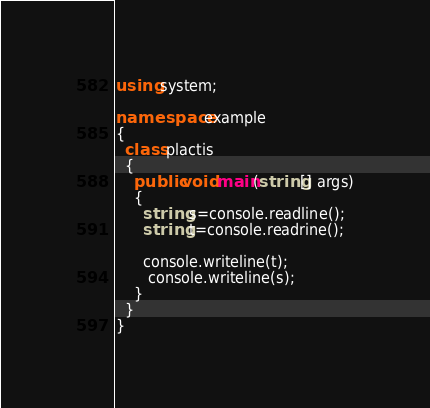Convert code to text. <code><loc_0><loc_0><loc_500><loc_500><_C#_>using system;
 
namespace example
{
  class plactis
  {
    public void main(string[] args)
    {
      string s=console.readline();
      string t=console.readrine();
      
      console.writeline(t);
       console.writeline(s);
    }
  }
}</code> 